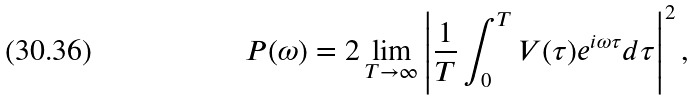<formula> <loc_0><loc_0><loc_500><loc_500>P ( \omega ) = 2 \lim _ { T \rightarrow \infty } \left | \frac { 1 } { T } \int _ { 0 } ^ { T } V ( \tau ) e ^ { i \omega \tau } d \tau \right | ^ { 2 } ,</formula> 